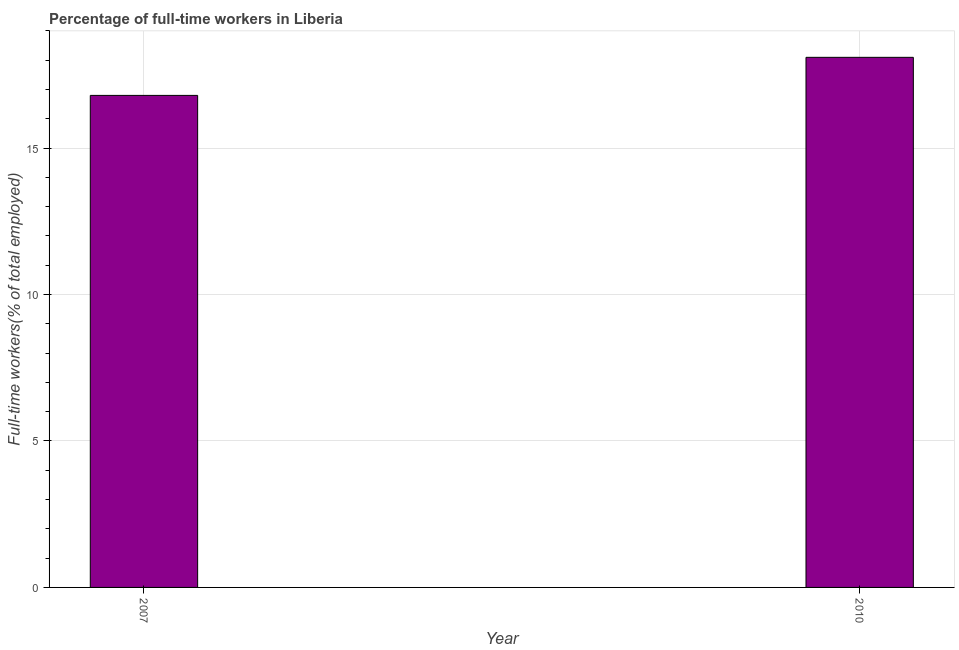Does the graph contain any zero values?
Your response must be concise. No. Does the graph contain grids?
Provide a short and direct response. Yes. What is the title of the graph?
Your answer should be very brief. Percentage of full-time workers in Liberia. What is the label or title of the X-axis?
Ensure brevity in your answer.  Year. What is the label or title of the Y-axis?
Give a very brief answer. Full-time workers(% of total employed). What is the percentage of full-time workers in 2010?
Your response must be concise. 18.1. Across all years, what is the maximum percentage of full-time workers?
Your answer should be very brief. 18.1. Across all years, what is the minimum percentage of full-time workers?
Ensure brevity in your answer.  16.8. In which year was the percentage of full-time workers maximum?
Make the answer very short. 2010. What is the sum of the percentage of full-time workers?
Offer a very short reply. 34.9. What is the difference between the percentage of full-time workers in 2007 and 2010?
Make the answer very short. -1.3. What is the average percentage of full-time workers per year?
Ensure brevity in your answer.  17.45. What is the median percentage of full-time workers?
Your answer should be very brief. 17.45. In how many years, is the percentage of full-time workers greater than 3 %?
Offer a terse response. 2. Do a majority of the years between 2010 and 2007 (inclusive) have percentage of full-time workers greater than 4 %?
Provide a short and direct response. No. What is the ratio of the percentage of full-time workers in 2007 to that in 2010?
Your answer should be very brief. 0.93. Is the percentage of full-time workers in 2007 less than that in 2010?
Give a very brief answer. Yes. How many bars are there?
Give a very brief answer. 2. How many years are there in the graph?
Keep it short and to the point. 2. Are the values on the major ticks of Y-axis written in scientific E-notation?
Give a very brief answer. No. What is the Full-time workers(% of total employed) in 2007?
Keep it short and to the point. 16.8. What is the Full-time workers(% of total employed) of 2010?
Provide a short and direct response. 18.1. What is the ratio of the Full-time workers(% of total employed) in 2007 to that in 2010?
Offer a very short reply. 0.93. 